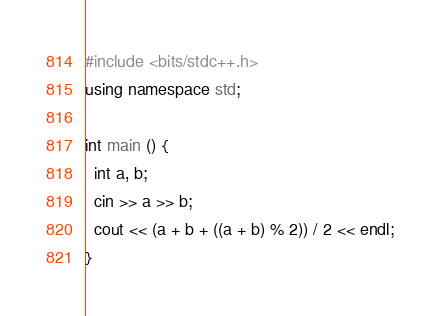Convert code to text. <code><loc_0><loc_0><loc_500><loc_500><_C++_>#include <bits/stdc++.h>
using namespace std;

int main () {
  int a, b;
  cin >> a >> b;
  cout << (a + b + ((a + b) % 2)) / 2 << endl;
}</code> 